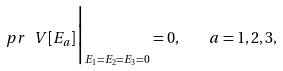<formula> <loc_0><loc_0><loc_500><loc_500>\ p r \, \ V [ E _ { a } ] \Big | _ { E _ { 1 } = E _ { 2 } = E _ { 3 } = 0 } = 0 , \quad a = 1 , 2 , 3 ,</formula> 